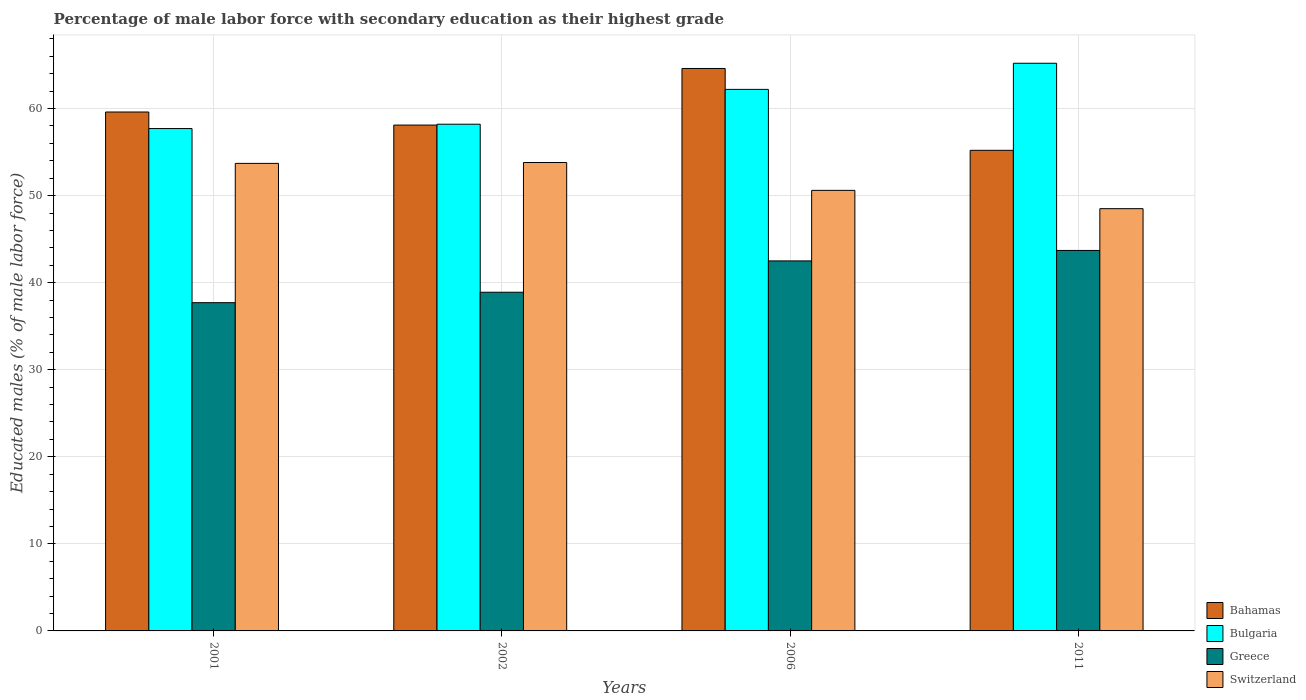How many different coloured bars are there?
Make the answer very short. 4. How many bars are there on the 4th tick from the left?
Keep it short and to the point. 4. How many bars are there on the 1st tick from the right?
Make the answer very short. 4. What is the percentage of male labor force with secondary education in Greece in 2011?
Ensure brevity in your answer.  43.7. Across all years, what is the maximum percentage of male labor force with secondary education in Bulgaria?
Keep it short and to the point. 65.2. Across all years, what is the minimum percentage of male labor force with secondary education in Bulgaria?
Offer a very short reply. 57.7. In which year was the percentage of male labor force with secondary education in Bahamas minimum?
Your response must be concise. 2011. What is the total percentage of male labor force with secondary education in Switzerland in the graph?
Your response must be concise. 206.6. What is the difference between the percentage of male labor force with secondary education in Greece in 2002 and that in 2006?
Your answer should be compact. -3.6. What is the difference between the percentage of male labor force with secondary education in Bahamas in 2006 and the percentage of male labor force with secondary education in Bulgaria in 2002?
Keep it short and to the point. 6.4. What is the average percentage of male labor force with secondary education in Greece per year?
Your answer should be very brief. 40.7. In the year 2001, what is the difference between the percentage of male labor force with secondary education in Greece and percentage of male labor force with secondary education in Bahamas?
Keep it short and to the point. -21.9. What is the ratio of the percentage of male labor force with secondary education in Greece in 2001 to that in 2011?
Ensure brevity in your answer.  0.86. What is the difference between the highest and the second highest percentage of male labor force with secondary education in Greece?
Offer a terse response. 1.2. What is the difference between the highest and the lowest percentage of male labor force with secondary education in Bulgaria?
Keep it short and to the point. 7.5. In how many years, is the percentage of male labor force with secondary education in Bahamas greater than the average percentage of male labor force with secondary education in Bahamas taken over all years?
Give a very brief answer. 2. Is it the case that in every year, the sum of the percentage of male labor force with secondary education in Greece and percentage of male labor force with secondary education in Switzerland is greater than the sum of percentage of male labor force with secondary education in Bahamas and percentage of male labor force with secondary education in Bulgaria?
Make the answer very short. No. Is it the case that in every year, the sum of the percentage of male labor force with secondary education in Greece and percentage of male labor force with secondary education in Switzerland is greater than the percentage of male labor force with secondary education in Bulgaria?
Make the answer very short. Yes. How many bars are there?
Provide a short and direct response. 16. How many years are there in the graph?
Ensure brevity in your answer.  4. Does the graph contain any zero values?
Keep it short and to the point. No. Does the graph contain grids?
Ensure brevity in your answer.  Yes. Where does the legend appear in the graph?
Your response must be concise. Bottom right. How many legend labels are there?
Ensure brevity in your answer.  4. What is the title of the graph?
Provide a short and direct response. Percentage of male labor force with secondary education as their highest grade. Does "Russian Federation" appear as one of the legend labels in the graph?
Your answer should be compact. No. What is the label or title of the Y-axis?
Offer a terse response. Educated males (% of male labor force). What is the Educated males (% of male labor force) in Bahamas in 2001?
Keep it short and to the point. 59.6. What is the Educated males (% of male labor force) in Bulgaria in 2001?
Provide a short and direct response. 57.7. What is the Educated males (% of male labor force) in Greece in 2001?
Offer a very short reply. 37.7. What is the Educated males (% of male labor force) of Switzerland in 2001?
Your answer should be compact. 53.7. What is the Educated males (% of male labor force) in Bahamas in 2002?
Your answer should be very brief. 58.1. What is the Educated males (% of male labor force) in Bulgaria in 2002?
Provide a succinct answer. 58.2. What is the Educated males (% of male labor force) of Greece in 2002?
Your answer should be compact. 38.9. What is the Educated males (% of male labor force) of Switzerland in 2002?
Offer a very short reply. 53.8. What is the Educated males (% of male labor force) in Bahamas in 2006?
Keep it short and to the point. 64.6. What is the Educated males (% of male labor force) in Bulgaria in 2006?
Provide a succinct answer. 62.2. What is the Educated males (% of male labor force) in Greece in 2006?
Ensure brevity in your answer.  42.5. What is the Educated males (% of male labor force) of Switzerland in 2006?
Your answer should be very brief. 50.6. What is the Educated males (% of male labor force) of Bahamas in 2011?
Offer a very short reply. 55.2. What is the Educated males (% of male labor force) in Bulgaria in 2011?
Provide a short and direct response. 65.2. What is the Educated males (% of male labor force) in Greece in 2011?
Keep it short and to the point. 43.7. What is the Educated males (% of male labor force) of Switzerland in 2011?
Your answer should be very brief. 48.5. Across all years, what is the maximum Educated males (% of male labor force) in Bahamas?
Provide a short and direct response. 64.6. Across all years, what is the maximum Educated males (% of male labor force) in Bulgaria?
Keep it short and to the point. 65.2. Across all years, what is the maximum Educated males (% of male labor force) in Greece?
Give a very brief answer. 43.7. Across all years, what is the maximum Educated males (% of male labor force) in Switzerland?
Keep it short and to the point. 53.8. Across all years, what is the minimum Educated males (% of male labor force) of Bahamas?
Provide a short and direct response. 55.2. Across all years, what is the minimum Educated males (% of male labor force) in Bulgaria?
Ensure brevity in your answer.  57.7. Across all years, what is the minimum Educated males (% of male labor force) in Greece?
Your answer should be very brief. 37.7. Across all years, what is the minimum Educated males (% of male labor force) in Switzerland?
Keep it short and to the point. 48.5. What is the total Educated males (% of male labor force) of Bahamas in the graph?
Ensure brevity in your answer.  237.5. What is the total Educated males (% of male labor force) in Bulgaria in the graph?
Offer a very short reply. 243.3. What is the total Educated males (% of male labor force) in Greece in the graph?
Your answer should be compact. 162.8. What is the total Educated males (% of male labor force) in Switzerland in the graph?
Make the answer very short. 206.6. What is the difference between the Educated males (% of male labor force) of Bulgaria in 2001 and that in 2002?
Ensure brevity in your answer.  -0.5. What is the difference between the Educated males (% of male labor force) of Greece in 2001 and that in 2002?
Your answer should be compact. -1.2. What is the difference between the Educated males (% of male labor force) in Bahamas in 2001 and that in 2006?
Offer a terse response. -5. What is the difference between the Educated males (% of male labor force) of Bulgaria in 2001 and that in 2006?
Give a very brief answer. -4.5. What is the difference between the Educated males (% of male labor force) in Switzerland in 2001 and that in 2006?
Your answer should be very brief. 3.1. What is the difference between the Educated males (% of male labor force) of Greece in 2001 and that in 2011?
Your answer should be very brief. -6. What is the difference between the Educated males (% of male labor force) in Switzerland in 2001 and that in 2011?
Your response must be concise. 5.2. What is the difference between the Educated males (% of male labor force) of Bahamas in 2002 and that in 2006?
Offer a terse response. -6.5. What is the difference between the Educated males (% of male labor force) in Greece in 2002 and that in 2006?
Keep it short and to the point. -3.6. What is the difference between the Educated males (% of male labor force) in Bahamas in 2002 and that in 2011?
Give a very brief answer. 2.9. What is the difference between the Educated males (% of male labor force) in Greece in 2002 and that in 2011?
Give a very brief answer. -4.8. What is the difference between the Educated males (% of male labor force) in Bahamas in 2006 and that in 2011?
Keep it short and to the point. 9.4. What is the difference between the Educated males (% of male labor force) in Bulgaria in 2006 and that in 2011?
Offer a terse response. -3. What is the difference between the Educated males (% of male labor force) in Bahamas in 2001 and the Educated males (% of male labor force) in Greece in 2002?
Ensure brevity in your answer.  20.7. What is the difference between the Educated males (% of male labor force) of Bulgaria in 2001 and the Educated males (% of male labor force) of Switzerland in 2002?
Your answer should be very brief. 3.9. What is the difference between the Educated males (% of male labor force) in Greece in 2001 and the Educated males (% of male labor force) in Switzerland in 2002?
Offer a very short reply. -16.1. What is the difference between the Educated males (% of male labor force) of Bahamas in 2001 and the Educated males (% of male labor force) of Bulgaria in 2006?
Offer a terse response. -2.6. What is the difference between the Educated males (% of male labor force) of Bahamas in 2001 and the Educated males (% of male labor force) of Greece in 2006?
Provide a succinct answer. 17.1. What is the difference between the Educated males (% of male labor force) of Bahamas in 2001 and the Educated males (% of male labor force) of Bulgaria in 2011?
Provide a short and direct response. -5.6. What is the difference between the Educated males (% of male labor force) of Bahamas in 2001 and the Educated males (% of male labor force) of Switzerland in 2011?
Ensure brevity in your answer.  11.1. What is the difference between the Educated males (% of male labor force) in Bulgaria in 2001 and the Educated males (% of male labor force) in Switzerland in 2011?
Your answer should be compact. 9.2. What is the difference between the Educated males (% of male labor force) in Bahamas in 2002 and the Educated males (% of male labor force) in Greece in 2006?
Offer a very short reply. 15.6. What is the difference between the Educated males (% of male labor force) of Bahamas in 2002 and the Educated males (% of male labor force) of Switzerland in 2006?
Offer a very short reply. 7.5. What is the difference between the Educated males (% of male labor force) in Greece in 2002 and the Educated males (% of male labor force) in Switzerland in 2011?
Offer a very short reply. -9.6. What is the difference between the Educated males (% of male labor force) of Bahamas in 2006 and the Educated males (% of male labor force) of Greece in 2011?
Offer a terse response. 20.9. What is the difference between the Educated males (% of male labor force) of Bahamas in 2006 and the Educated males (% of male labor force) of Switzerland in 2011?
Offer a very short reply. 16.1. What is the difference between the Educated males (% of male labor force) of Bulgaria in 2006 and the Educated males (% of male labor force) of Greece in 2011?
Provide a short and direct response. 18.5. What is the difference between the Educated males (% of male labor force) in Bulgaria in 2006 and the Educated males (% of male labor force) in Switzerland in 2011?
Offer a terse response. 13.7. What is the average Educated males (% of male labor force) of Bahamas per year?
Make the answer very short. 59.38. What is the average Educated males (% of male labor force) in Bulgaria per year?
Provide a short and direct response. 60.83. What is the average Educated males (% of male labor force) in Greece per year?
Offer a very short reply. 40.7. What is the average Educated males (% of male labor force) in Switzerland per year?
Provide a succinct answer. 51.65. In the year 2001, what is the difference between the Educated males (% of male labor force) of Bahamas and Educated males (% of male labor force) of Greece?
Ensure brevity in your answer.  21.9. In the year 2001, what is the difference between the Educated males (% of male labor force) in Bulgaria and Educated males (% of male labor force) in Greece?
Your answer should be very brief. 20. In the year 2001, what is the difference between the Educated males (% of male labor force) in Greece and Educated males (% of male labor force) in Switzerland?
Provide a short and direct response. -16. In the year 2002, what is the difference between the Educated males (% of male labor force) in Bahamas and Educated males (% of male labor force) in Bulgaria?
Give a very brief answer. -0.1. In the year 2002, what is the difference between the Educated males (% of male labor force) in Bulgaria and Educated males (% of male labor force) in Greece?
Your answer should be very brief. 19.3. In the year 2002, what is the difference between the Educated males (% of male labor force) of Bulgaria and Educated males (% of male labor force) of Switzerland?
Offer a terse response. 4.4. In the year 2002, what is the difference between the Educated males (% of male labor force) of Greece and Educated males (% of male labor force) of Switzerland?
Your response must be concise. -14.9. In the year 2006, what is the difference between the Educated males (% of male labor force) of Bahamas and Educated males (% of male labor force) of Bulgaria?
Give a very brief answer. 2.4. In the year 2006, what is the difference between the Educated males (% of male labor force) of Bahamas and Educated males (% of male labor force) of Greece?
Offer a very short reply. 22.1. In the year 2006, what is the difference between the Educated males (% of male labor force) of Bahamas and Educated males (% of male labor force) of Switzerland?
Your answer should be compact. 14. In the year 2006, what is the difference between the Educated males (% of male labor force) in Bulgaria and Educated males (% of male labor force) in Greece?
Provide a succinct answer. 19.7. In the year 2006, what is the difference between the Educated males (% of male labor force) of Bulgaria and Educated males (% of male labor force) of Switzerland?
Make the answer very short. 11.6. In the year 2006, what is the difference between the Educated males (% of male labor force) of Greece and Educated males (% of male labor force) of Switzerland?
Give a very brief answer. -8.1. In the year 2011, what is the difference between the Educated males (% of male labor force) in Bahamas and Educated males (% of male labor force) in Bulgaria?
Provide a short and direct response. -10. In the year 2011, what is the difference between the Educated males (% of male labor force) of Bahamas and Educated males (% of male labor force) of Greece?
Give a very brief answer. 11.5. In the year 2011, what is the difference between the Educated males (% of male labor force) of Bulgaria and Educated males (% of male labor force) of Greece?
Provide a short and direct response. 21.5. In the year 2011, what is the difference between the Educated males (% of male labor force) in Bulgaria and Educated males (% of male labor force) in Switzerland?
Ensure brevity in your answer.  16.7. What is the ratio of the Educated males (% of male labor force) of Bahamas in 2001 to that in 2002?
Keep it short and to the point. 1.03. What is the ratio of the Educated males (% of male labor force) of Bulgaria in 2001 to that in 2002?
Give a very brief answer. 0.99. What is the ratio of the Educated males (% of male labor force) of Greece in 2001 to that in 2002?
Your answer should be very brief. 0.97. What is the ratio of the Educated males (% of male labor force) in Bahamas in 2001 to that in 2006?
Keep it short and to the point. 0.92. What is the ratio of the Educated males (% of male labor force) in Bulgaria in 2001 to that in 2006?
Your answer should be very brief. 0.93. What is the ratio of the Educated males (% of male labor force) of Greece in 2001 to that in 2006?
Provide a succinct answer. 0.89. What is the ratio of the Educated males (% of male labor force) of Switzerland in 2001 to that in 2006?
Your response must be concise. 1.06. What is the ratio of the Educated males (% of male labor force) of Bahamas in 2001 to that in 2011?
Keep it short and to the point. 1.08. What is the ratio of the Educated males (% of male labor force) in Bulgaria in 2001 to that in 2011?
Provide a succinct answer. 0.89. What is the ratio of the Educated males (% of male labor force) in Greece in 2001 to that in 2011?
Your answer should be compact. 0.86. What is the ratio of the Educated males (% of male labor force) in Switzerland in 2001 to that in 2011?
Give a very brief answer. 1.11. What is the ratio of the Educated males (% of male labor force) of Bahamas in 2002 to that in 2006?
Ensure brevity in your answer.  0.9. What is the ratio of the Educated males (% of male labor force) of Bulgaria in 2002 to that in 2006?
Make the answer very short. 0.94. What is the ratio of the Educated males (% of male labor force) in Greece in 2002 to that in 2006?
Provide a short and direct response. 0.92. What is the ratio of the Educated males (% of male labor force) in Switzerland in 2002 to that in 2006?
Keep it short and to the point. 1.06. What is the ratio of the Educated males (% of male labor force) in Bahamas in 2002 to that in 2011?
Provide a succinct answer. 1.05. What is the ratio of the Educated males (% of male labor force) of Bulgaria in 2002 to that in 2011?
Keep it short and to the point. 0.89. What is the ratio of the Educated males (% of male labor force) of Greece in 2002 to that in 2011?
Provide a succinct answer. 0.89. What is the ratio of the Educated males (% of male labor force) of Switzerland in 2002 to that in 2011?
Keep it short and to the point. 1.11. What is the ratio of the Educated males (% of male labor force) of Bahamas in 2006 to that in 2011?
Your answer should be compact. 1.17. What is the ratio of the Educated males (% of male labor force) of Bulgaria in 2006 to that in 2011?
Make the answer very short. 0.95. What is the ratio of the Educated males (% of male labor force) of Greece in 2006 to that in 2011?
Offer a very short reply. 0.97. What is the ratio of the Educated males (% of male labor force) in Switzerland in 2006 to that in 2011?
Ensure brevity in your answer.  1.04. What is the difference between the highest and the second highest Educated males (% of male labor force) of Bulgaria?
Offer a very short reply. 3. What is the difference between the highest and the lowest Educated males (% of male labor force) in Bahamas?
Ensure brevity in your answer.  9.4. What is the difference between the highest and the lowest Educated males (% of male labor force) of Bulgaria?
Your response must be concise. 7.5. What is the difference between the highest and the lowest Educated males (% of male labor force) in Switzerland?
Provide a succinct answer. 5.3. 